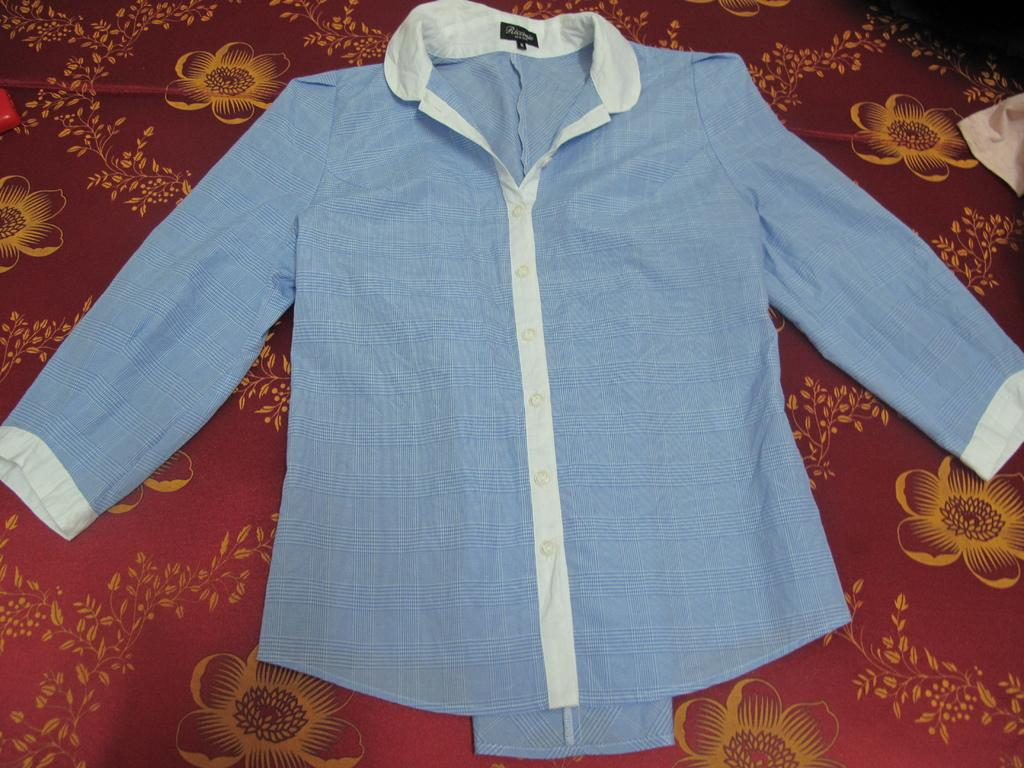What type of shirt is visible in the image? There is a blue shirt with white lines in the image. What color is the cloth surface that the shirt is on? The cloth surface is maroon. What design can be seen on the cloth surface? The cloth surface has flower designs. How many times does the knife appear in the image? There is no knife present in the image. 